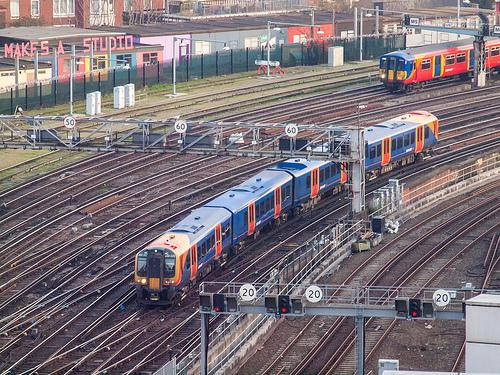Question: what color are the doors on the farther train?
Choices:
A. Blue.
B. Black.
C. White.
D. Green.
Answer with the letter. Answer: A Question: where is the picture taken?
Choices:
A. Train station.
B. Train tracks.
C. Warehouse.
D. Train yard.
Answer with the letter. Answer: D Question: how many trains are visible?
Choices:
A. 2.
B. 7.
C. 8.
D. 9.
Answer with the letter. Answer: A Question: what number is closest?
Choices:
A. 16.
B. 42.
C. 20.
D. 11.
Answer with the letter. Answer: C Question: what number is above the closest train?
Choices:
A. 17.
B. 60.
C. 65.
D. 53.
Answer with the letter. Answer: B 